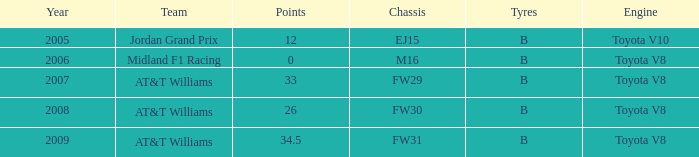What is the low point total after 2006 with an m16 chassis? None. 